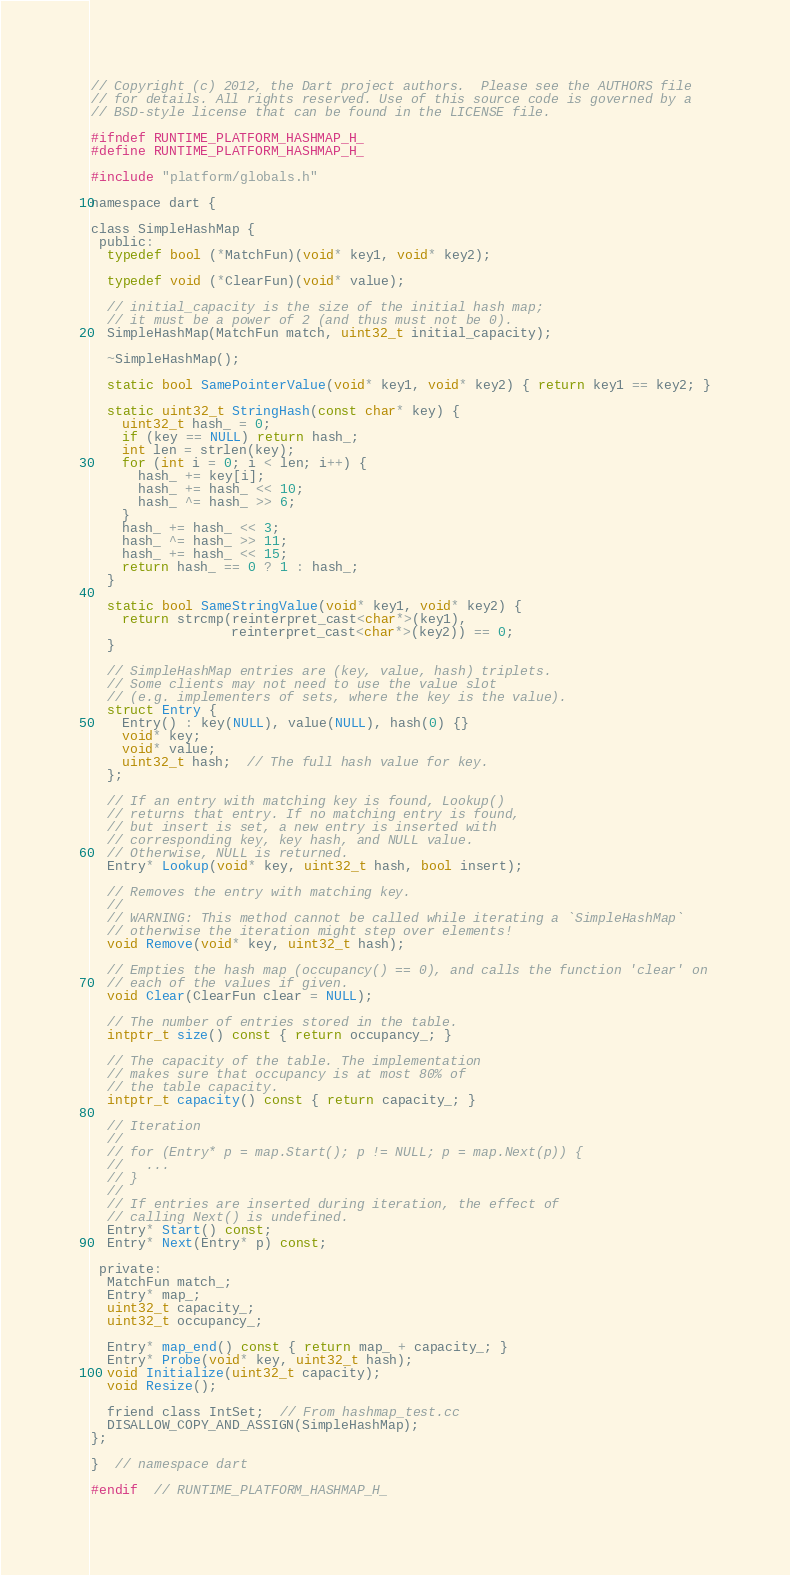<code> <loc_0><loc_0><loc_500><loc_500><_C_>// Copyright (c) 2012, the Dart project authors.  Please see the AUTHORS file
// for details. All rights reserved. Use of this source code is governed by a
// BSD-style license that can be found in the LICENSE file.

#ifndef RUNTIME_PLATFORM_HASHMAP_H_
#define RUNTIME_PLATFORM_HASHMAP_H_

#include "platform/globals.h"

namespace dart {

class SimpleHashMap {
 public:
  typedef bool (*MatchFun)(void* key1, void* key2);

  typedef void (*ClearFun)(void* value);

  // initial_capacity is the size of the initial hash map;
  // it must be a power of 2 (and thus must not be 0).
  SimpleHashMap(MatchFun match, uint32_t initial_capacity);

  ~SimpleHashMap();

  static bool SamePointerValue(void* key1, void* key2) { return key1 == key2; }

  static uint32_t StringHash(const char* key) {
    uint32_t hash_ = 0;
    if (key == NULL) return hash_;
    int len = strlen(key);
    for (int i = 0; i < len; i++) {
      hash_ += key[i];
      hash_ += hash_ << 10;
      hash_ ^= hash_ >> 6;
    }
    hash_ += hash_ << 3;
    hash_ ^= hash_ >> 11;
    hash_ += hash_ << 15;
    return hash_ == 0 ? 1 : hash_;
  }

  static bool SameStringValue(void* key1, void* key2) {
    return strcmp(reinterpret_cast<char*>(key1),
                  reinterpret_cast<char*>(key2)) == 0;
  }

  // SimpleHashMap entries are (key, value, hash) triplets.
  // Some clients may not need to use the value slot
  // (e.g. implementers of sets, where the key is the value).
  struct Entry {
    Entry() : key(NULL), value(NULL), hash(0) {}
    void* key;
    void* value;
    uint32_t hash;  // The full hash value for key.
  };

  // If an entry with matching key is found, Lookup()
  // returns that entry. If no matching entry is found,
  // but insert is set, a new entry is inserted with
  // corresponding key, key hash, and NULL value.
  // Otherwise, NULL is returned.
  Entry* Lookup(void* key, uint32_t hash, bool insert);

  // Removes the entry with matching key.
  //
  // WARNING: This method cannot be called while iterating a `SimpleHashMap`
  // otherwise the iteration might step over elements!
  void Remove(void* key, uint32_t hash);

  // Empties the hash map (occupancy() == 0), and calls the function 'clear' on
  // each of the values if given.
  void Clear(ClearFun clear = NULL);

  // The number of entries stored in the table.
  intptr_t size() const { return occupancy_; }

  // The capacity of the table. The implementation
  // makes sure that occupancy is at most 80% of
  // the table capacity.
  intptr_t capacity() const { return capacity_; }

  // Iteration
  //
  // for (Entry* p = map.Start(); p != NULL; p = map.Next(p)) {
  //   ...
  // }
  //
  // If entries are inserted during iteration, the effect of
  // calling Next() is undefined.
  Entry* Start() const;
  Entry* Next(Entry* p) const;

 private:
  MatchFun match_;
  Entry* map_;
  uint32_t capacity_;
  uint32_t occupancy_;

  Entry* map_end() const { return map_ + capacity_; }
  Entry* Probe(void* key, uint32_t hash);
  void Initialize(uint32_t capacity);
  void Resize();

  friend class IntSet;  // From hashmap_test.cc
  DISALLOW_COPY_AND_ASSIGN(SimpleHashMap);
};

}  // namespace dart

#endif  // RUNTIME_PLATFORM_HASHMAP_H_
</code> 